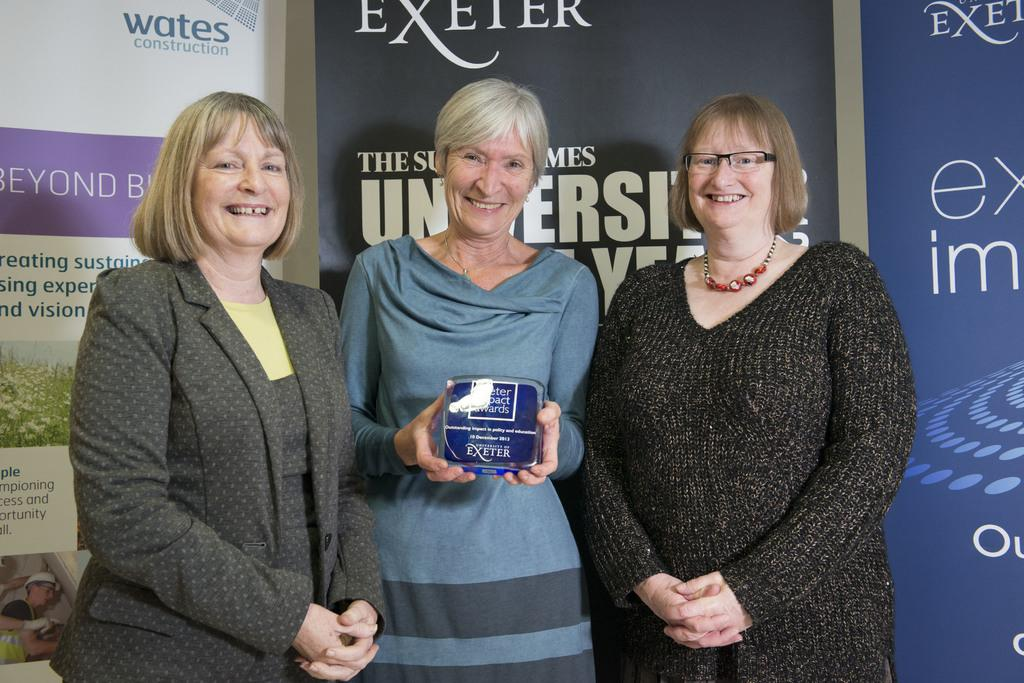What is the main subject of the image? There is a person holding an object in the center of the image. Who else is present in the image? There are two other people beside the person in the center. What is the facial expression of the two people? The two people have smiles on their faces. What can be seen in the background of the image? There are banners visible in the background. What type of doctor is standing next to the person holding the object? There is no doctor present in the image. 